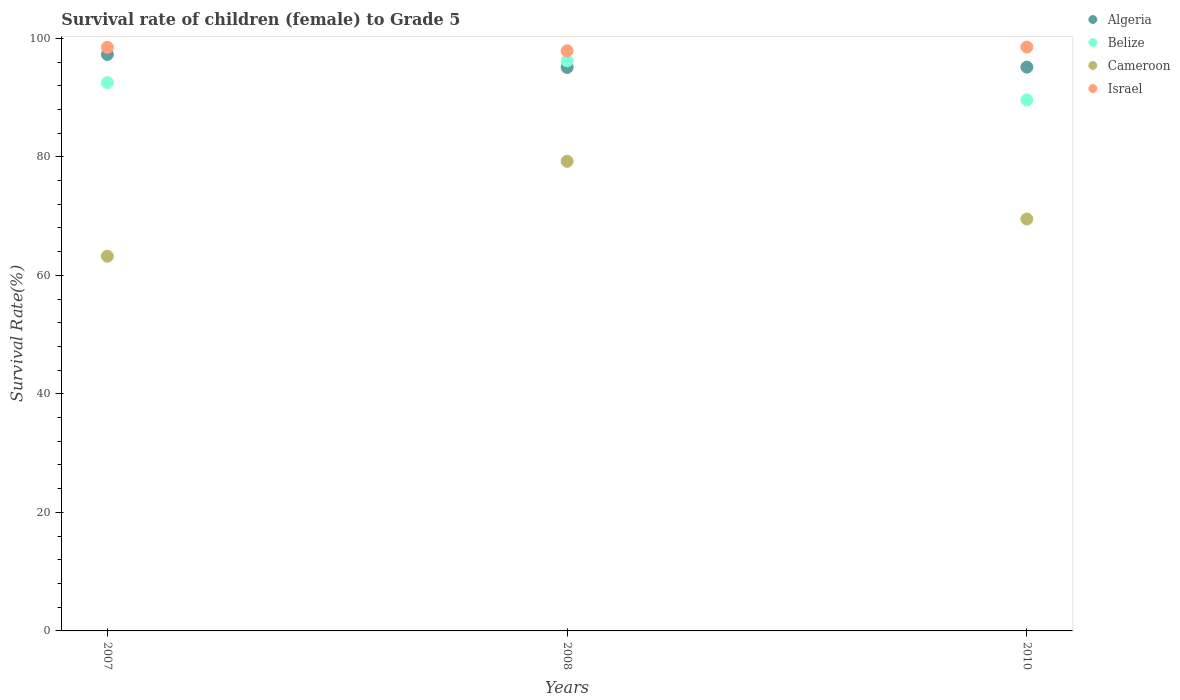How many different coloured dotlines are there?
Provide a short and direct response. 4. What is the survival rate of female children to grade 5 in Israel in 2010?
Make the answer very short. 98.53. Across all years, what is the maximum survival rate of female children to grade 5 in Algeria?
Your answer should be very brief. 97.27. Across all years, what is the minimum survival rate of female children to grade 5 in Cameroon?
Give a very brief answer. 63.22. In which year was the survival rate of female children to grade 5 in Algeria minimum?
Your answer should be compact. 2008. What is the total survival rate of female children to grade 5 in Cameroon in the graph?
Keep it short and to the point. 211.97. What is the difference between the survival rate of female children to grade 5 in Belize in 2008 and that in 2010?
Ensure brevity in your answer.  6.58. What is the difference between the survival rate of female children to grade 5 in Algeria in 2007 and the survival rate of female children to grade 5 in Israel in 2008?
Your response must be concise. -0.62. What is the average survival rate of female children to grade 5 in Cameroon per year?
Keep it short and to the point. 70.66. In the year 2008, what is the difference between the survival rate of female children to grade 5 in Israel and survival rate of female children to grade 5 in Algeria?
Ensure brevity in your answer.  2.81. What is the ratio of the survival rate of female children to grade 5 in Cameroon in 2008 to that in 2010?
Keep it short and to the point. 1.14. Is the survival rate of female children to grade 5 in Belize in 2007 less than that in 2010?
Offer a very short reply. No. What is the difference between the highest and the second highest survival rate of female children to grade 5 in Cameroon?
Your answer should be very brief. 9.74. What is the difference between the highest and the lowest survival rate of female children to grade 5 in Belize?
Provide a succinct answer. 6.58. Is it the case that in every year, the sum of the survival rate of female children to grade 5 in Cameroon and survival rate of female children to grade 5 in Israel  is greater than the sum of survival rate of female children to grade 5 in Belize and survival rate of female children to grade 5 in Algeria?
Keep it short and to the point. No. Is it the case that in every year, the sum of the survival rate of female children to grade 5 in Algeria and survival rate of female children to grade 5 in Israel  is greater than the survival rate of female children to grade 5 in Cameroon?
Provide a succinct answer. Yes. Does the survival rate of female children to grade 5 in Israel monotonically increase over the years?
Offer a very short reply. No. Is the survival rate of female children to grade 5 in Algeria strictly greater than the survival rate of female children to grade 5 in Israel over the years?
Make the answer very short. No. How many dotlines are there?
Provide a succinct answer. 4. What is the difference between two consecutive major ticks on the Y-axis?
Provide a short and direct response. 20. Are the values on the major ticks of Y-axis written in scientific E-notation?
Your response must be concise. No. Does the graph contain grids?
Offer a terse response. No. Where does the legend appear in the graph?
Your answer should be compact. Top right. How many legend labels are there?
Offer a very short reply. 4. How are the legend labels stacked?
Offer a terse response. Vertical. What is the title of the graph?
Provide a short and direct response. Survival rate of children (female) to Grade 5. What is the label or title of the Y-axis?
Make the answer very short. Survival Rate(%). What is the Survival Rate(%) of Algeria in 2007?
Make the answer very short. 97.27. What is the Survival Rate(%) of Belize in 2007?
Keep it short and to the point. 92.51. What is the Survival Rate(%) in Cameroon in 2007?
Ensure brevity in your answer.  63.22. What is the Survival Rate(%) in Israel in 2007?
Offer a terse response. 98.48. What is the Survival Rate(%) in Algeria in 2008?
Offer a very short reply. 95.08. What is the Survival Rate(%) of Belize in 2008?
Give a very brief answer. 96.19. What is the Survival Rate(%) in Cameroon in 2008?
Ensure brevity in your answer.  79.25. What is the Survival Rate(%) in Israel in 2008?
Give a very brief answer. 97.89. What is the Survival Rate(%) of Algeria in 2010?
Make the answer very short. 95.13. What is the Survival Rate(%) in Belize in 2010?
Give a very brief answer. 89.61. What is the Survival Rate(%) of Cameroon in 2010?
Your response must be concise. 69.5. What is the Survival Rate(%) in Israel in 2010?
Provide a succinct answer. 98.53. Across all years, what is the maximum Survival Rate(%) of Algeria?
Provide a succinct answer. 97.27. Across all years, what is the maximum Survival Rate(%) of Belize?
Your answer should be very brief. 96.19. Across all years, what is the maximum Survival Rate(%) of Cameroon?
Offer a very short reply. 79.25. Across all years, what is the maximum Survival Rate(%) of Israel?
Your answer should be very brief. 98.53. Across all years, what is the minimum Survival Rate(%) in Algeria?
Your response must be concise. 95.08. Across all years, what is the minimum Survival Rate(%) in Belize?
Offer a terse response. 89.61. Across all years, what is the minimum Survival Rate(%) of Cameroon?
Keep it short and to the point. 63.22. Across all years, what is the minimum Survival Rate(%) in Israel?
Give a very brief answer. 97.89. What is the total Survival Rate(%) of Algeria in the graph?
Your response must be concise. 287.48. What is the total Survival Rate(%) in Belize in the graph?
Offer a very short reply. 278.32. What is the total Survival Rate(%) of Cameroon in the graph?
Offer a very short reply. 211.97. What is the total Survival Rate(%) of Israel in the graph?
Provide a short and direct response. 294.89. What is the difference between the Survival Rate(%) of Algeria in 2007 and that in 2008?
Provide a succinct answer. 2.19. What is the difference between the Survival Rate(%) of Belize in 2007 and that in 2008?
Ensure brevity in your answer.  -3.68. What is the difference between the Survival Rate(%) in Cameroon in 2007 and that in 2008?
Ensure brevity in your answer.  -16.02. What is the difference between the Survival Rate(%) in Israel in 2007 and that in 2008?
Your answer should be very brief. 0.59. What is the difference between the Survival Rate(%) of Algeria in 2007 and that in 2010?
Your answer should be compact. 2.14. What is the difference between the Survival Rate(%) in Belize in 2007 and that in 2010?
Give a very brief answer. 2.91. What is the difference between the Survival Rate(%) of Cameroon in 2007 and that in 2010?
Provide a short and direct response. -6.28. What is the difference between the Survival Rate(%) of Israel in 2007 and that in 2010?
Keep it short and to the point. -0.05. What is the difference between the Survival Rate(%) in Algeria in 2008 and that in 2010?
Provide a succinct answer. -0.05. What is the difference between the Survival Rate(%) in Belize in 2008 and that in 2010?
Offer a terse response. 6.58. What is the difference between the Survival Rate(%) of Cameroon in 2008 and that in 2010?
Keep it short and to the point. 9.74. What is the difference between the Survival Rate(%) of Israel in 2008 and that in 2010?
Your answer should be compact. -0.64. What is the difference between the Survival Rate(%) in Algeria in 2007 and the Survival Rate(%) in Belize in 2008?
Provide a succinct answer. 1.08. What is the difference between the Survival Rate(%) of Algeria in 2007 and the Survival Rate(%) of Cameroon in 2008?
Offer a very short reply. 18.02. What is the difference between the Survival Rate(%) in Algeria in 2007 and the Survival Rate(%) in Israel in 2008?
Keep it short and to the point. -0.62. What is the difference between the Survival Rate(%) in Belize in 2007 and the Survival Rate(%) in Cameroon in 2008?
Your response must be concise. 13.27. What is the difference between the Survival Rate(%) in Belize in 2007 and the Survival Rate(%) in Israel in 2008?
Offer a very short reply. -5.37. What is the difference between the Survival Rate(%) in Cameroon in 2007 and the Survival Rate(%) in Israel in 2008?
Ensure brevity in your answer.  -34.66. What is the difference between the Survival Rate(%) of Algeria in 2007 and the Survival Rate(%) of Belize in 2010?
Offer a terse response. 7.66. What is the difference between the Survival Rate(%) in Algeria in 2007 and the Survival Rate(%) in Cameroon in 2010?
Your answer should be very brief. 27.77. What is the difference between the Survival Rate(%) in Algeria in 2007 and the Survival Rate(%) in Israel in 2010?
Your response must be concise. -1.26. What is the difference between the Survival Rate(%) of Belize in 2007 and the Survival Rate(%) of Cameroon in 2010?
Offer a terse response. 23.01. What is the difference between the Survival Rate(%) in Belize in 2007 and the Survival Rate(%) in Israel in 2010?
Ensure brevity in your answer.  -6.01. What is the difference between the Survival Rate(%) of Cameroon in 2007 and the Survival Rate(%) of Israel in 2010?
Offer a terse response. -35.3. What is the difference between the Survival Rate(%) in Algeria in 2008 and the Survival Rate(%) in Belize in 2010?
Your answer should be very brief. 5.47. What is the difference between the Survival Rate(%) of Algeria in 2008 and the Survival Rate(%) of Cameroon in 2010?
Your answer should be very brief. 25.58. What is the difference between the Survival Rate(%) in Algeria in 2008 and the Survival Rate(%) in Israel in 2010?
Ensure brevity in your answer.  -3.44. What is the difference between the Survival Rate(%) in Belize in 2008 and the Survival Rate(%) in Cameroon in 2010?
Your response must be concise. 26.69. What is the difference between the Survival Rate(%) of Belize in 2008 and the Survival Rate(%) of Israel in 2010?
Your response must be concise. -2.33. What is the difference between the Survival Rate(%) in Cameroon in 2008 and the Survival Rate(%) in Israel in 2010?
Your answer should be very brief. -19.28. What is the average Survival Rate(%) in Algeria per year?
Provide a succinct answer. 95.83. What is the average Survival Rate(%) in Belize per year?
Your response must be concise. 92.77. What is the average Survival Rate(%) of Cameroon per year?
Your answer should be very brief. 70.66. What is the average Survival Rate(%) of Israel per year?
Give a very brief answer. 98.3. In the year 2007, what is the difference between the Survival Rate(%) of Algeria and Survival Rate(%) of Belize?
Provide a succinct answer. 4.76. In the year 2007, what is the difference between the Survival Rate(%) of Algeria and Survival Rate(%) of Cameroon?
Ensure brevity in your answer.  34.05. In the year 2007, what is the difference between the Survival Rate(%) in Algeria and Survival Rate(%) in Israel?
Give a very brief answer. -1.21. In the year 2007, what is the difference between the Survival Rate(%) in Belize and Survival Rate(%) in Cameroon?
Give a very brief answer. 29.29. In the year 2007, what is the difference between the Survival Rate(%) of Belize and Survival Rate(%) of Israel?
Provide a short and direct response. -5.97. In the year 2007, what is the difference between the Survival Rate(%) of Cameroon and Survival Rate(%) of Israel?
Keep it short and to the point. -35.26. In the year 2008, what is the difference between the Survival Rate(%) of Algeria and Survival Rate(%) of Belize?
Give a very brief answer. -1.11. In the year 2008, what is the difference between the Survival Rate(%) of Algeria and Survival Rate(%) of Cameroon?
Make the answer very short. 15.84. In the year 2008, what is the difference between the Survival Rate(%) of Algeria and Survival Rate(%) of Israel?
Provide a short and direct response. -2.81. In the year 2008, what is the difference between the Survival Rate(%) in Belize and Survival Rate(%) in Cameroon?
Provide a succinct answer. 16.95. In the year 2008, what is the difference between the Survival Rate(%) of Belize and Survival Rate(%) of Israel?
Provide a succinct answer. -1.69. In the year 2008, what is the difference between the Survival Rate(%) in Cameroon and Survival Rate(%) in Israel?
Your answer should be compact. -18.64. In the year 2010, what is the difference between the Survival Rate(%) of Algeria and Survival Rate(%) of Belize?
Provide a succinct answer. 5.52. In the year 2010, what is the difference between the Survival Rate(%) of Algeria and Survival Rate(%) of Cameroon?
Make the answer very short. 25.63. In the year 2010, what is the difference between the Survival Rate(%) of Algeria and Survival Rate(%) of Israel?
Make the answer very short. -3.39. In the year 2010, what is the difference between the Survival Rate(%) of Belize and Survival Rate(%) of Cameroon?
Ensure brevity in your answer.  20.11. In the year 2010, what is the difference between the Survival Rate(%) of Belize and Survival Rate(%) of Israel?
Your response must be concise. -8.92. In the year 2010, what is the difference between the Survival Rate(%) in Cameroon and Survival Rate(%) in Israel?
Provide a succinct answer. -29.02. What is the ratio of the Survival Rate(%) of Belize in 2007 to that in 2008?
Your response must be concise. 0.96. What is the ratio of the Survival Rate(%) of Cameroon in 2007 to that in 2008?
Give a very brief answer. 0.8. What is the ratio of the Survival Rate(%) of Algeria in 2007 to that in 2010?
Make the answer very short. 1.02. What is the ratio of the Survival Rate(%) of Belize in 2007 to that in 2010?
Provide a succinct answer. 1.03. What is the ratio of the Survival Rate(%) of Cameroon in 2007 to that in 2010?
Make the answer very short. 0.91. What is the ratio of the Survival Rate(%) of Belize in 2008 to that in 2010?
Keep it short and to the point. 1.07. What is the ratio of the Survival Rate(%) in Cameroon in 2008 to that in 2010?
Give a very brief answer. 1.14. What is the difference between the highest and the second highest Survival Rate(%) in Algeria?
Provide a succinct answer. 2.14. What is the difference between the highest and the second highest Survival Rate(%) of Belize?
Your answer should be very brief. 3.68. What is the difference between the highest and the second highest Survival Rate(%) in Cameroon?
Keep it short and to the point. 9.74. What is the difference between the highest and the second highest Survival Rate(%) in Israel?
Provide a short and direct response. 0.05. What is the difference between the highest and the lowest Survival Rate(%) in Algeria?
Provide a succinct answer. 2.19. What is the difference between the highest and the lowest Survival Rate(%) in Belize?
Provide a succinct answer. 6.58. What is the difference between the highest and the lowest Survival Rate(%) of Cameroon?
Ensure brevity in your answer.  16.02. What is the difference between the highest and the lowest Survival Rate(%) of Israel?
Provide a succinct answer. 0.64. 